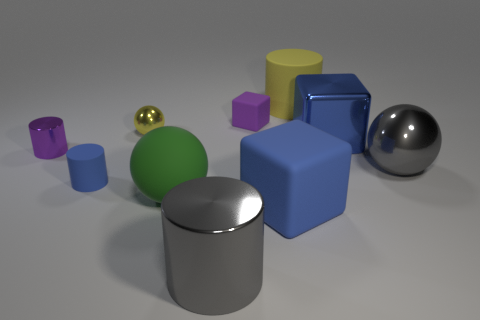Subtract 1 cylinders. How many cylinders are left? 3 Subtract all balls. How many objects are left? 7 Subtract 1 green spheres. How many objects are left? 9 Subtract all large objects. Subtract all cyan cubes. How many objects are left? 4 Add 2 yellow rubber cylinders. How many yellow rubber cylinders are left? 3 Add 3 big gray cylinders. How many big gray cylinders exist? 4 